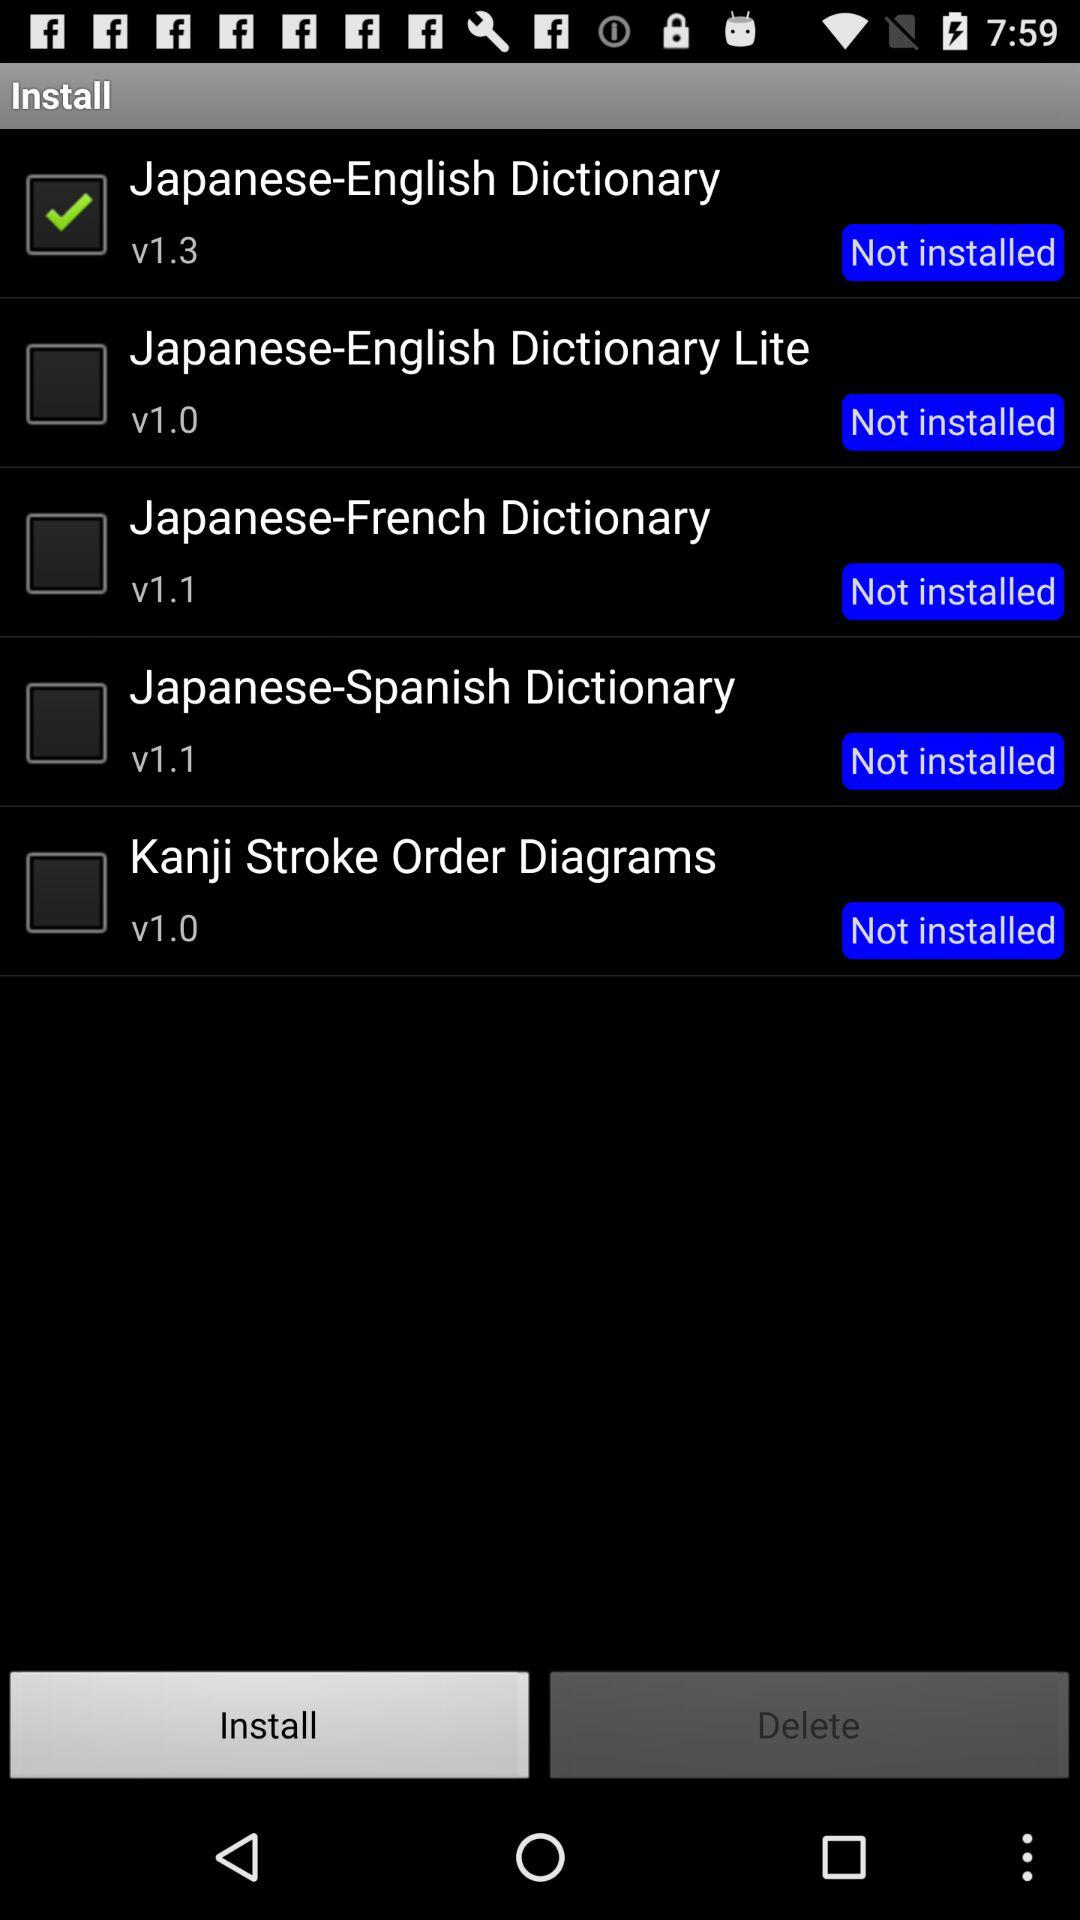Which dictionary is selected? The selected dictionary is "Japanese-English Dictionary". 